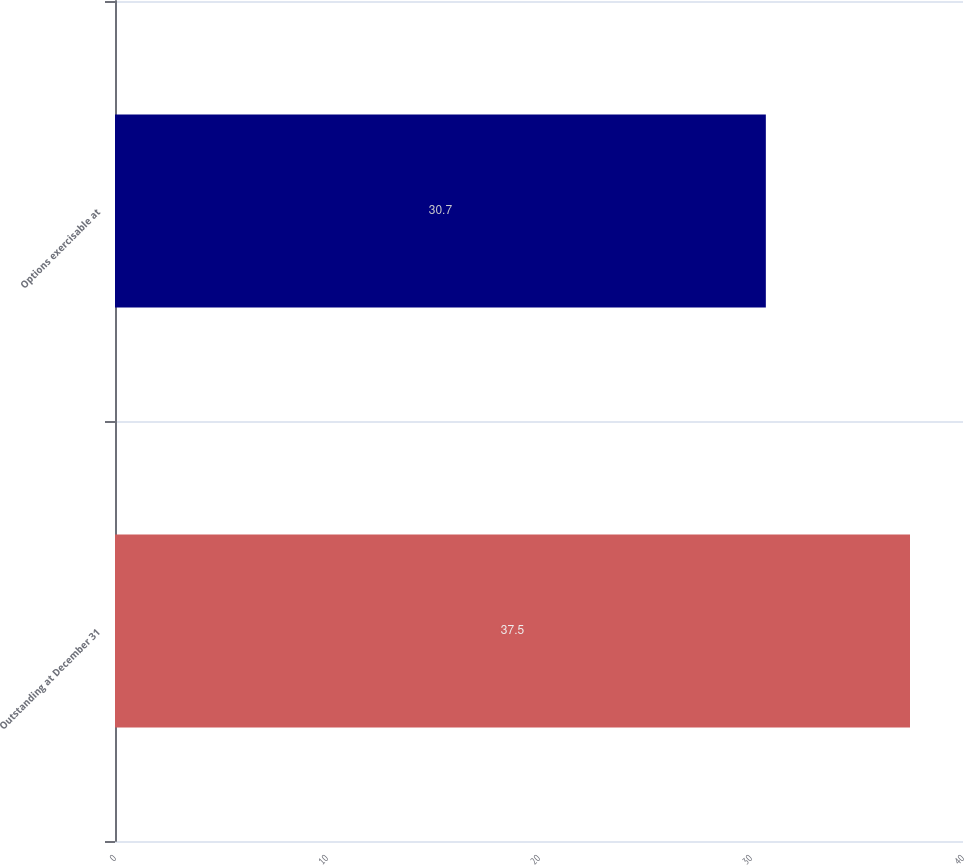Convert chart. <chart><loc_0><loc_0><loc_500><loc_500><bar_chart><fcel>Outstanding at December 31<fcel>Options exercisable at<nl><fcel>37.5<fcel>30.7<nl></chart> 